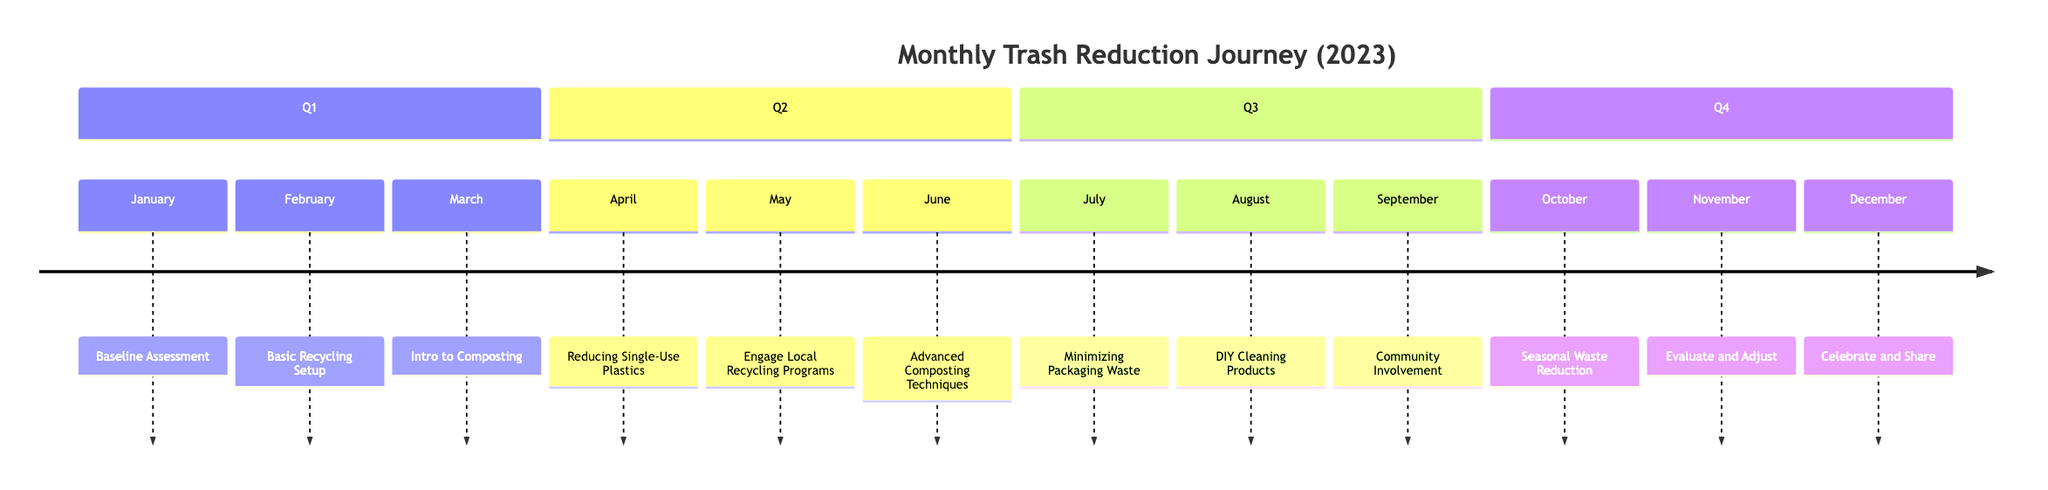What is the first activity in the timeline? The timeline starts with the month of January, which lists "Baseline Assessment" as the first activity.
Answer: Baseline Assessment How many activities are there in the second quarter? The second quarter consists of April, May, and June, which means there are three activities listed.
Answer: 3 What activity is scheduled for November? The timeline indicates that in November, the activity is "Evaluate and Adjust".
Answer: Evaluate and Adjust Which month focuses on reducing single-use plastics? According to the timeline, April is the month dedicated to "Reducing Single-Use Plastics".
Answer: April What is the last activity of the year? In December, the timeline shows that the last activity is "Celebrate and Share".
Answer: Celebrate and Share What are the activities in Q3? The third quarter consists of July, August, and September, which include "Minimizing Packaging Waste," "DIY Cleaning Products," and "Community Involvement".
Answer: Minimizing Packaging Waste, DIY Cleaning Products, Community Involvement How does the focus of activities change from Q1 to Q2? In Q1, activities primarily involve assessment and setup, while Q2 shifts towards actively engaging in reducing waste through recycling and composting techniques.
Answer: Engaging in reducing waste Which month introduces the concept of composting? "Intro to Composting" is introduced in March, marking the first mention of composting in the timeline.
Answer: March What is the central theme of the activities throughout the year? The central theme of the activities is to implement strategies for reducing waste, which encompasses recycling, composting, and minimizing single-use plastics.
Answer: Reducing waste 